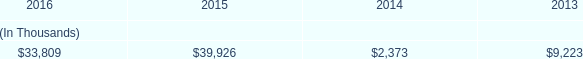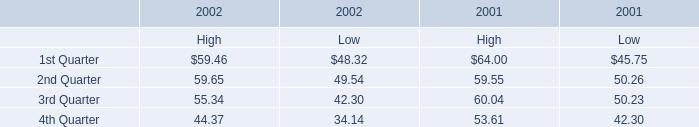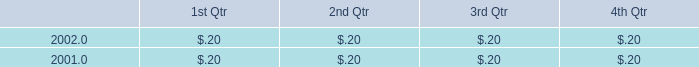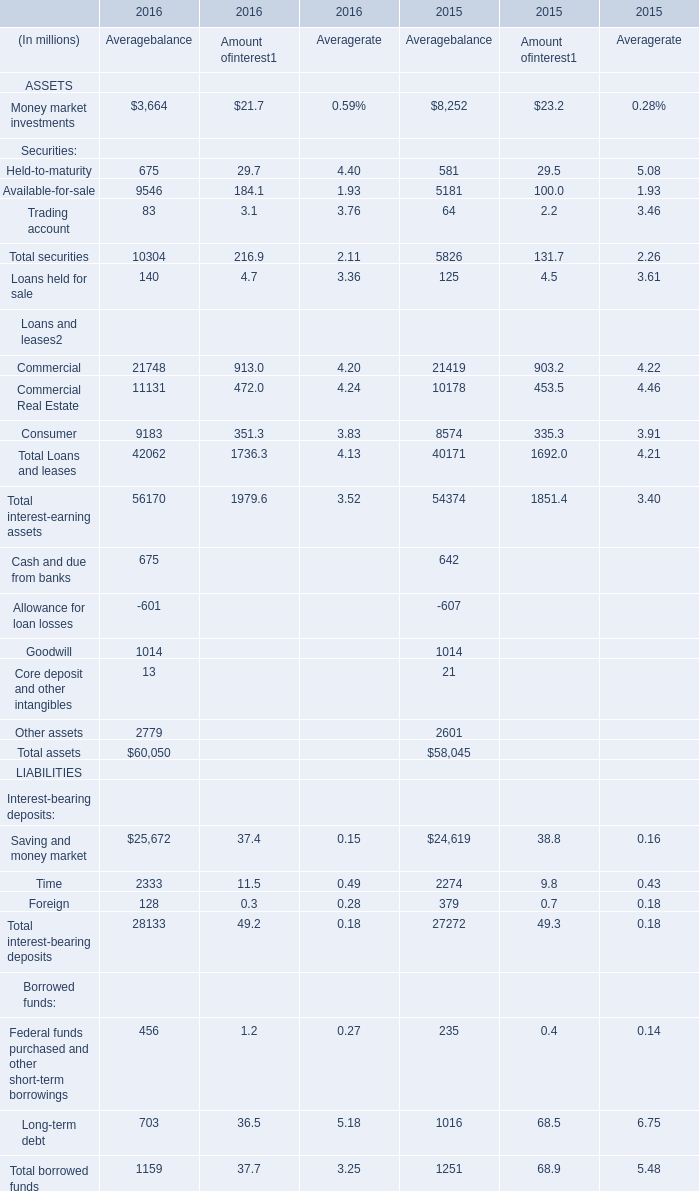What's the increasing rate of Trading account for Amount of interest in 2016? 
Computations: ((3.1 - 2.2) / 2.2)
Answer: 0.40909. 